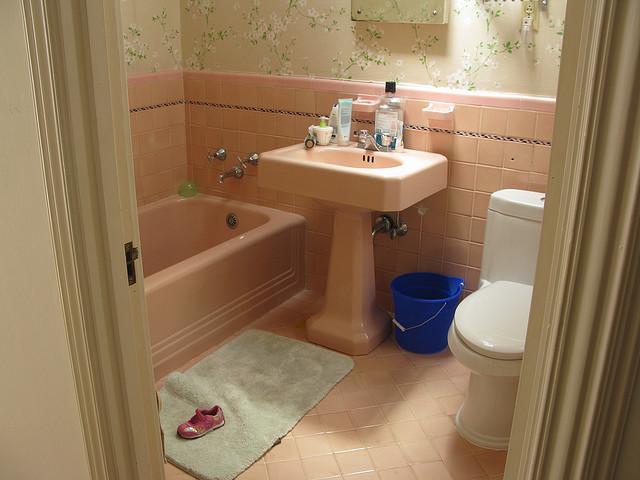What color is the sink?
Give a very brief answer. Pink. What color is the cup?
Answer briefly. White. Are the residents here tidy people?
Write a very short answer. Yes. What color is the tub?
Write a very short answer. Pink. What is under the sink?
Answer briefly. Bucket. Do the bathroom fixtures appear contemporary or outdated?
Concise answer only. Outdated. 